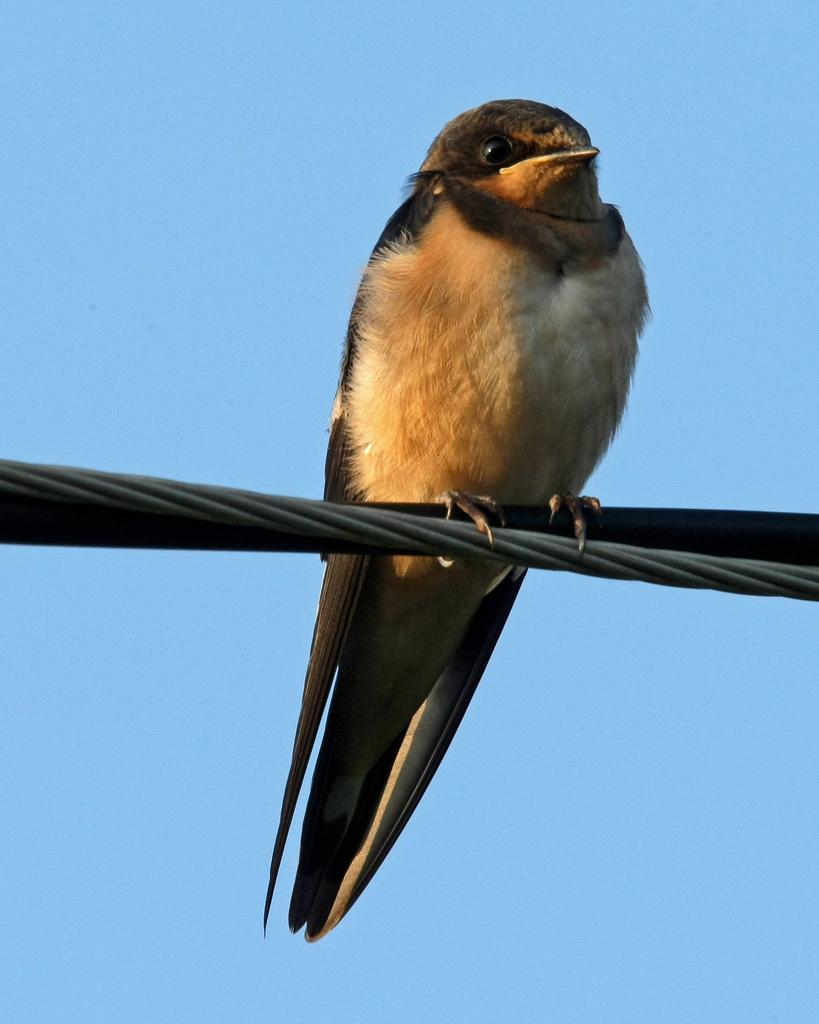What type of animal can be seen in the image? There is a bird in the image. Where is the bird located in the image? The bird is standing on a wire. What is the distance between the bird and the sun in the image? There is no sun visible in the image, so it is not possible to determine the distance between the bird and the sun. 